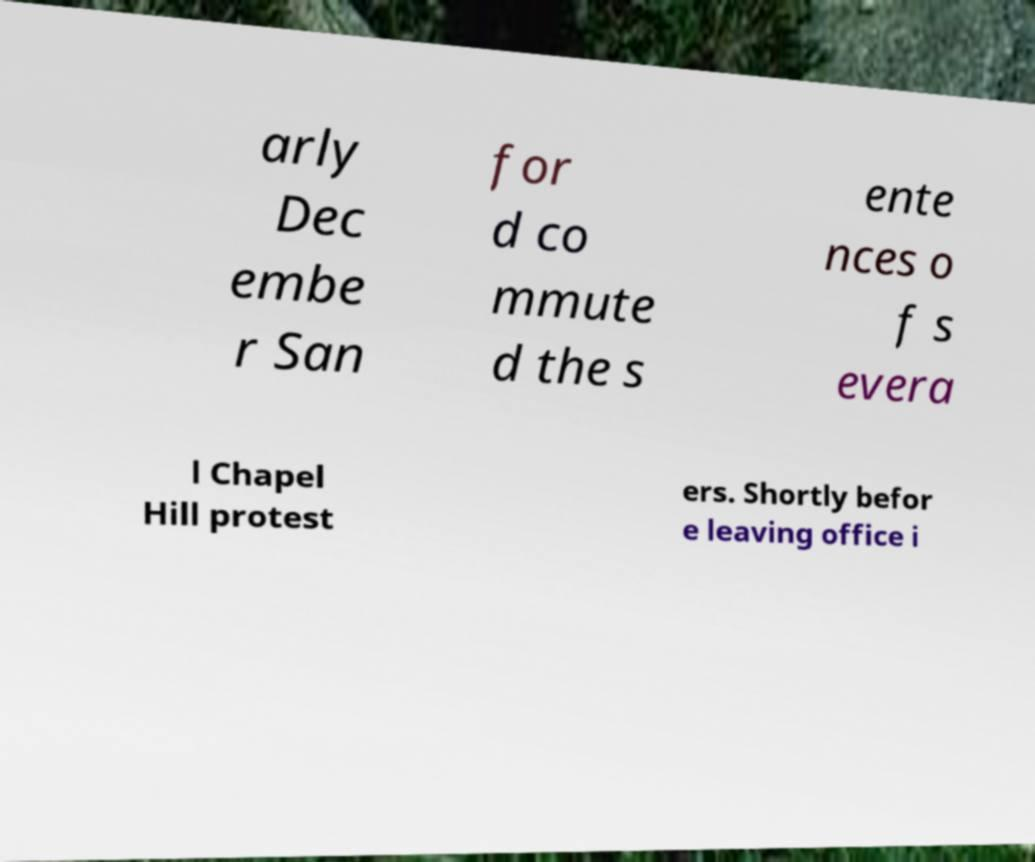What messages or text are displayed in this image? I need them in a readable, typed format. arly Dec embe r San for d co mmute d the s ente nces o f s evera l Chapel Hill protest ers. Shortly befor e leaving office i 